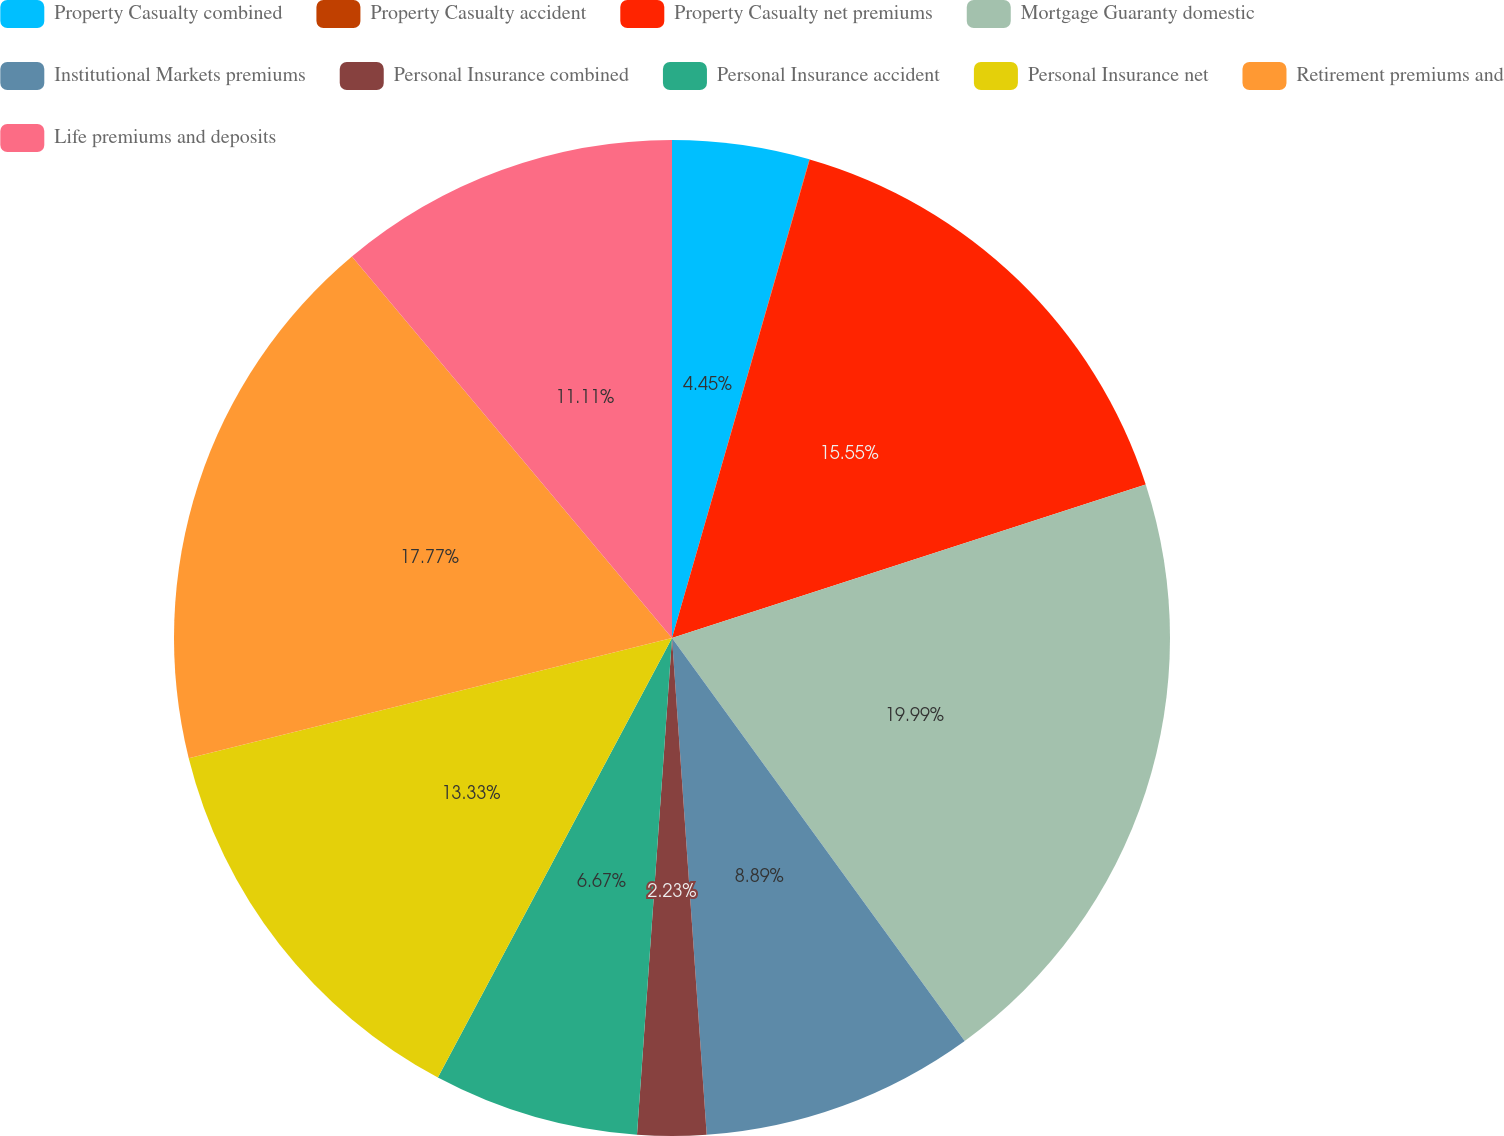Convert chart. <chart><loc_0><loc_0><loc_500><loc_500><pie_chart><fcel>Property Casualty combined<fcel>Property Casualty accident<fcel>Property Casualty net premiums<fcel>Mortgage Guaranty domestic<fcel>Institutional Markets premiums<fcel>Personal Insurance combined<fcel>Personal Insurance accident<fcel>Personal Insurance net<fcel>Retirement premiums and<fcel>Life premiums and deposits<nl><fcel>4.45%<fcel>0.01%<fcel>15.55%<fcel>19.99%<fcel>8.89%<fcel>2.23%<fcel>6.67%<fcel>13.33%<fcel>17.77%<fcel>11.11%<nl></chart> 